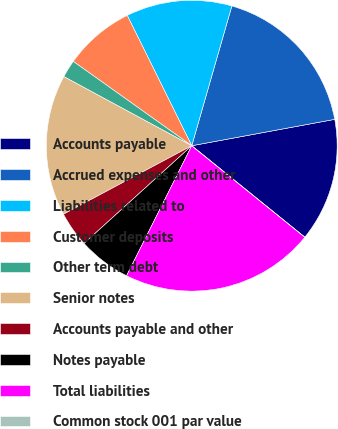<chart> <loc_0><loc_0><loc_500><loc_500><pie_chart><fcel>Accounts payable<fcel>Accrued expenses and other<fcel>Liabilities related to<fcel>Customer deposits<fcel>Other term debt<fcel>Senior notes<fcel>Accounts payable and other<fcel>Notes payable<fcel>Total liabilities<fcel>Common stock 001 par value<nl><fcel>13.73%<fcel>17.65%<fcel>11.76%<fcel>7.84%<fcel>1.96%<fcel>15.69%<fcel>3.92%<fcel>5.88%<fcel>21.57%<fcel>0.0%<nl></chart> 